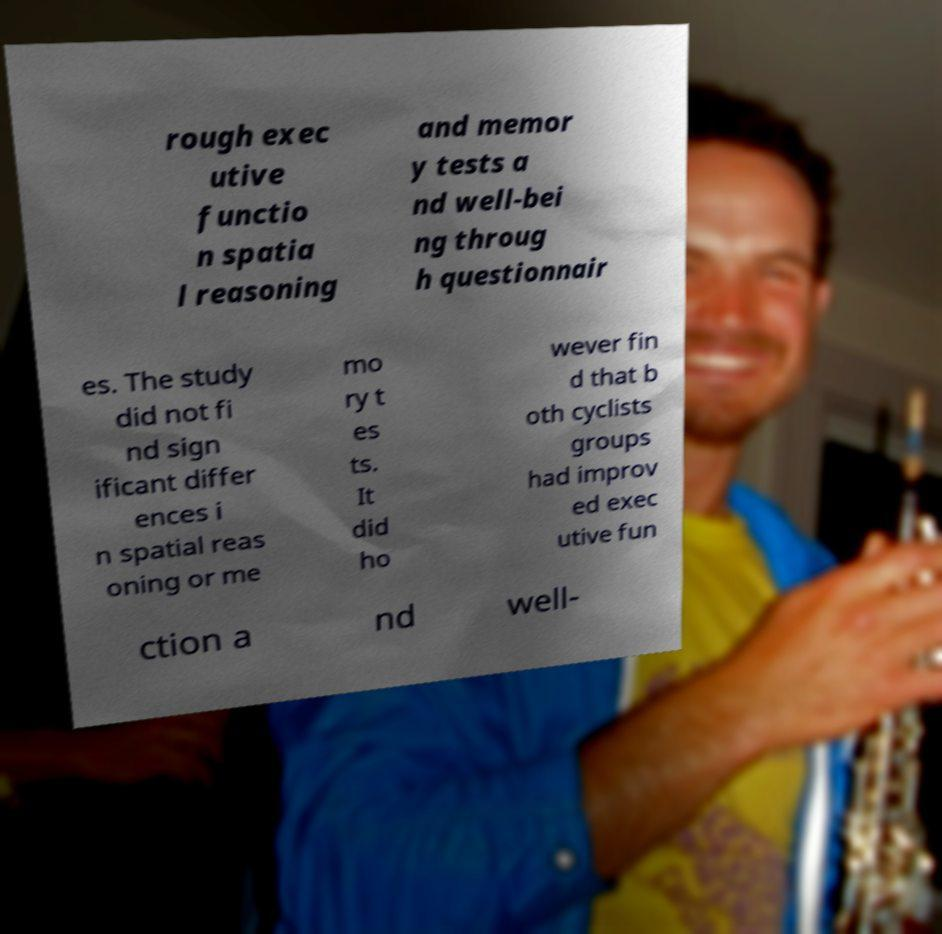What messages or text are displayed in this image? I need them in a readable, typed format. rough exec utive functio n spatia l reasoning and memor y tests a nd well-bei ng throug h questionnair es. The study did not fi nd sign ificant differ ences i n spatial reas oning or me mo ry t es ts. It did ho wever fin d that b oth cyclists groups had improv ed exec utive fun ction a nd well- 